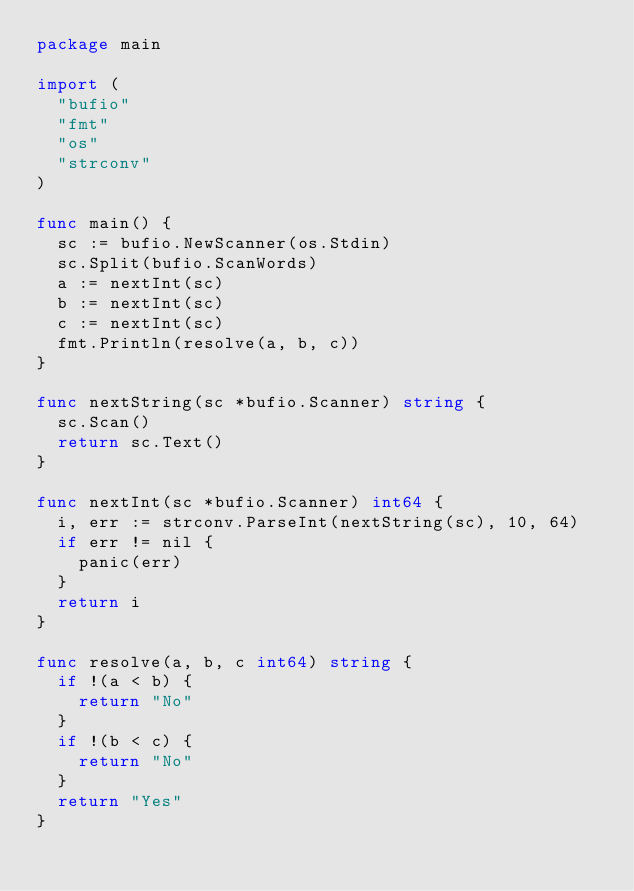Convert code to text. <code><loc_0><loc_0><loc_500><loc_500><_Go_>package main

import (
	"bufio"
	"fmt"
	"os"
	"strconv"
)

func main() {
	sc := bufio.NewScanner(os.Stdin)
	sc.Split(bufio.ScanWords)
	a := nextInt(sc)
	b := nextInt(sc)
	c := nextInt(sc)
	fmt.Println(resolve(a, b, c))
}

func nextString(sc *bufio.Scanner) string {
	sc.Scan()
	return sc.Text()
}

func nextInt(sc *bufio.Scanner) int64 {
	i, err := strconv.ParseInt(nextString(sc), 10, 64)
	if err != nil {
		panic(err)
	}
	return i
}

func resolve(a, b, c int64) string {
	if !(a < b) {
		return "No"
	}
	if !(b < c) {
		return "No"
	}
	return "Yes"
}

</code> 